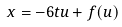Convert formula to latex. <formula><loc_0><loc_0><loc_500><loc_500>x = - 6 t u + f ( u )</formula> 